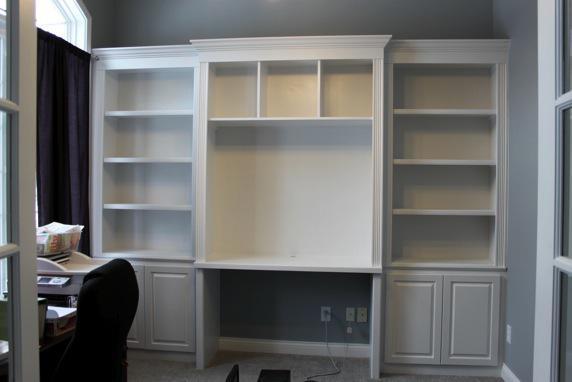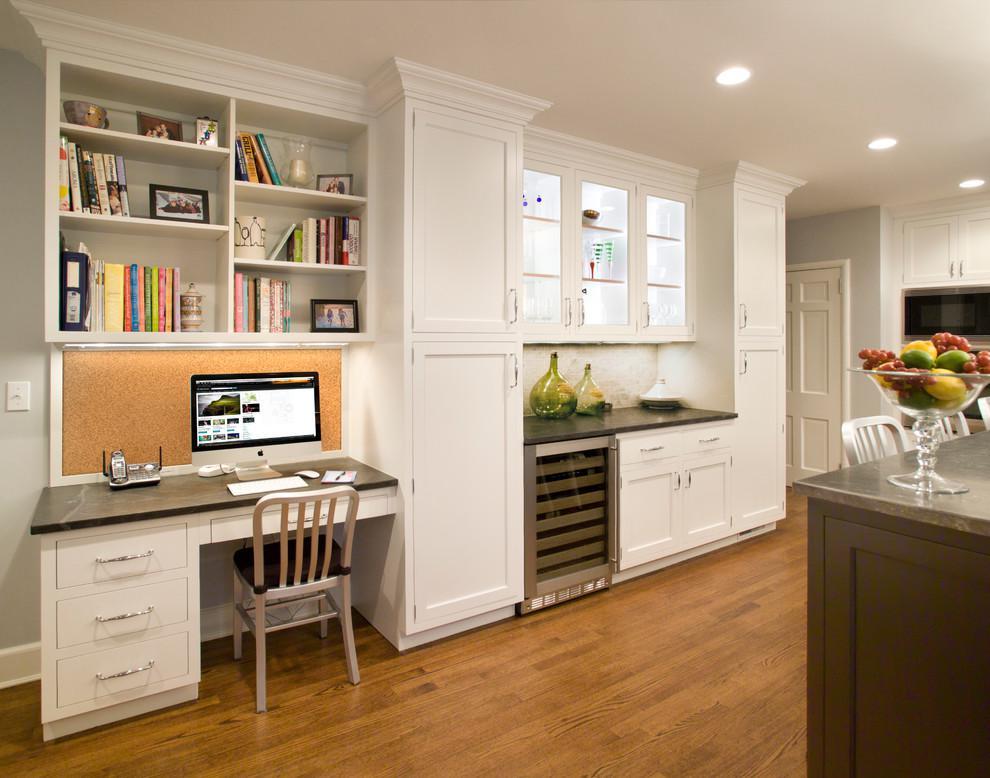The first image is the image on the left, the second image is the image on the right. Given the left and right images, does the statement "An image shows a chair pulled up to a white desk, which sits under a wall-mounted white shelf unit." hold true? Answer yes or no. Yes. The first image is the image on the left, the second image is the image on the right. Assess this claim about the two images: "In one image, a center desk space has two open upper shelving units on each side with corresponding closed units below.". Correct or not? Answer yes or no. No. 